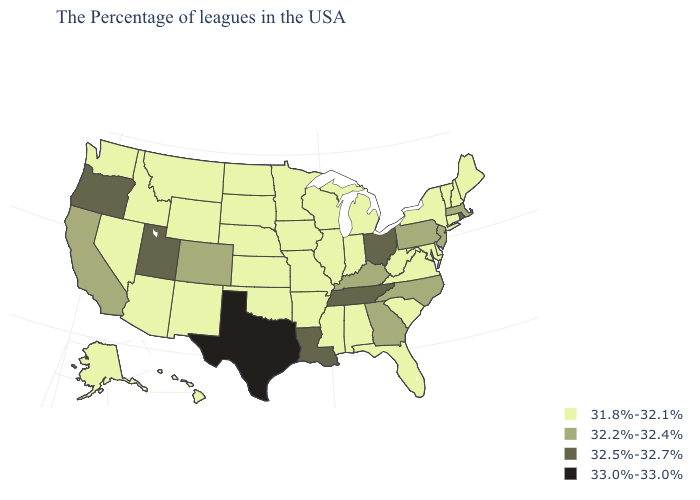What is the highest value in the West ?
Give a very brief answer. 32.5%-32.7%. Name the states that have a value in the range 32.5%-32.7%?
Write a very short answer. Rhode Island, Ohio, Tennessee, Louisiana, Utah, Oregon. Name the states that have a value in the range 32.5%-32.7%?
Be succinct. Rhode Island, Ohio, Tennessee, Louisiana, Utah, Oregon. Among the states that border Iowa , which have the highest value?
Quick response, please. Wisconsin, Illinois, Missouri, Minnesota, Nebraska, South Dakota. Is the legend a continuous bar?
Answer briefly. No. Name the states that have a value in the range 33.0%-33.0%?
Be succinct. Texas. What is the lowest value in the USA?
Concise answer only. 31.8%-32.1%. What is the lowest value in states that border Vermont?
Give a very brief answer. 31.8%-32.1%. What is the highest value in the West ?
Concise answer only. 32.5%-32.7%. Does the map have missing data?
Short answer required. No. What is the value of California?
Keep it brief. 32.2%-32.4%. Name the states that have a value in the range 32.5%-32.7%?
Give a very brief answer. Rhode Island, Ohio, Tennessee, Louisiana, Utah, Oregon. What is the value of Texas?
Answer briefly. 33.0%-33.0%. What is the lowest value in the USA?
Concise answer only. 31.8%-32.1%. Does Massachusetts have the highest value in the USA?
Keep it brief. No. 